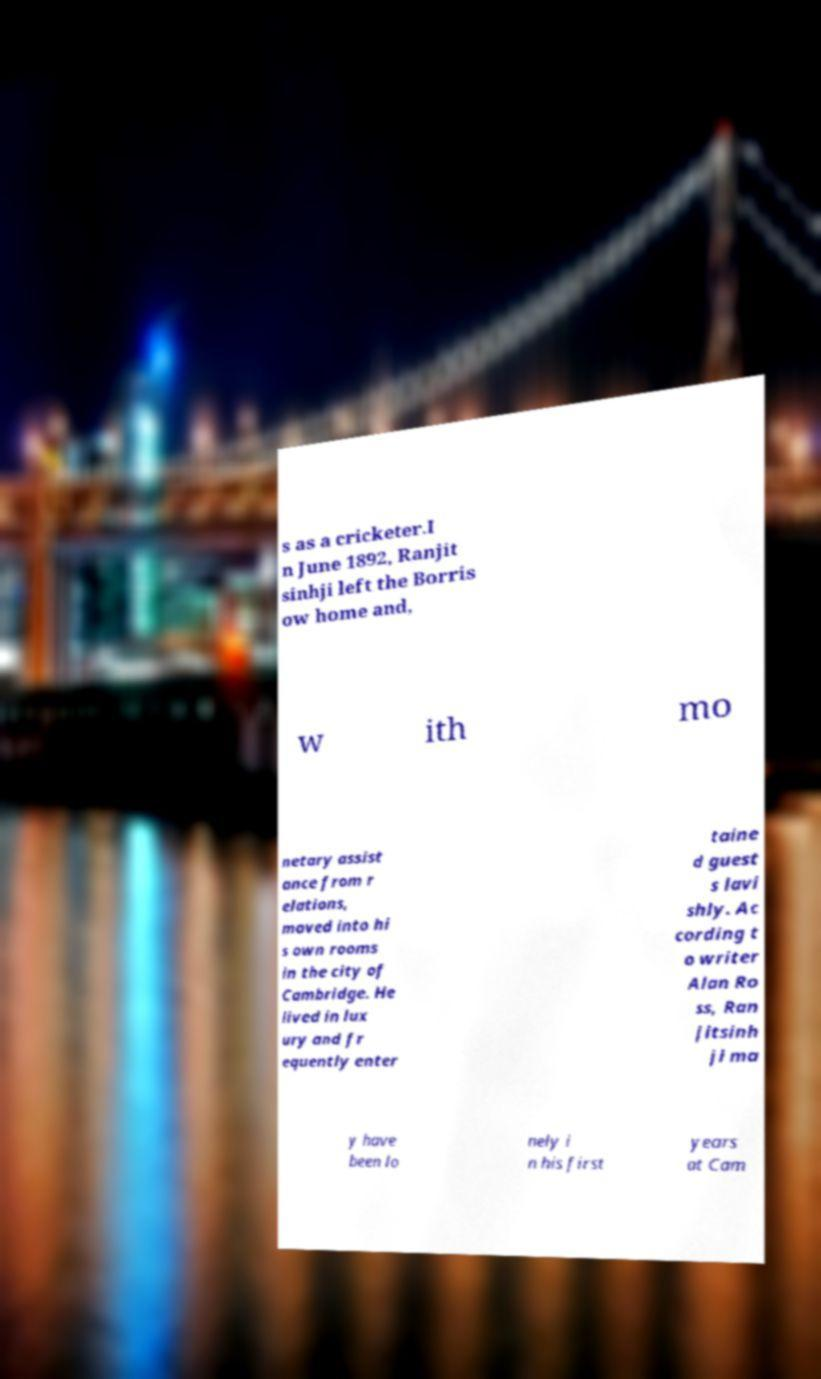Please read and relay the text visible in this image. What does it say? s as a cricketer.I n June 1892, Ranjit sinhji left the Borris ow home and, w ith mo netary assist ance from r elations, moved into hi s own rooms in the city of Cambridge. He lived in lux ury and fr equently enter taine d guest s lavi shly. Ac cording t o writer Alan Ro ss, Ran jitsinh ji ma y have been lo nely i n his first years at Cam 